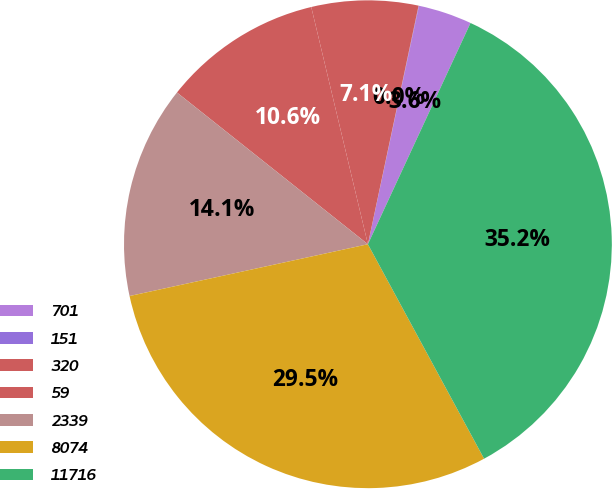<chart> <loc_0><loc_0><loc_500><loc_500><pie_chart><fcel>701<fcel>151<fcel>320<fcel>59<fcel>2339<fcel>8074<fcel>11716<nl><fcel>3.55%<fcel>0.03%<fcel>7.06%<fcel>10.58%<fcel>14.09%<fcel>29.49%<fcel>35.18%<nl></chart> 